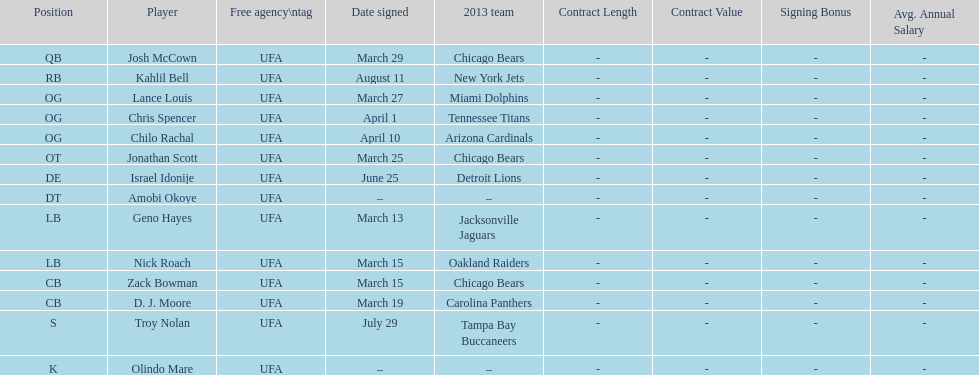Nick roach was signed the same day as what other player? Zack Bowman. 